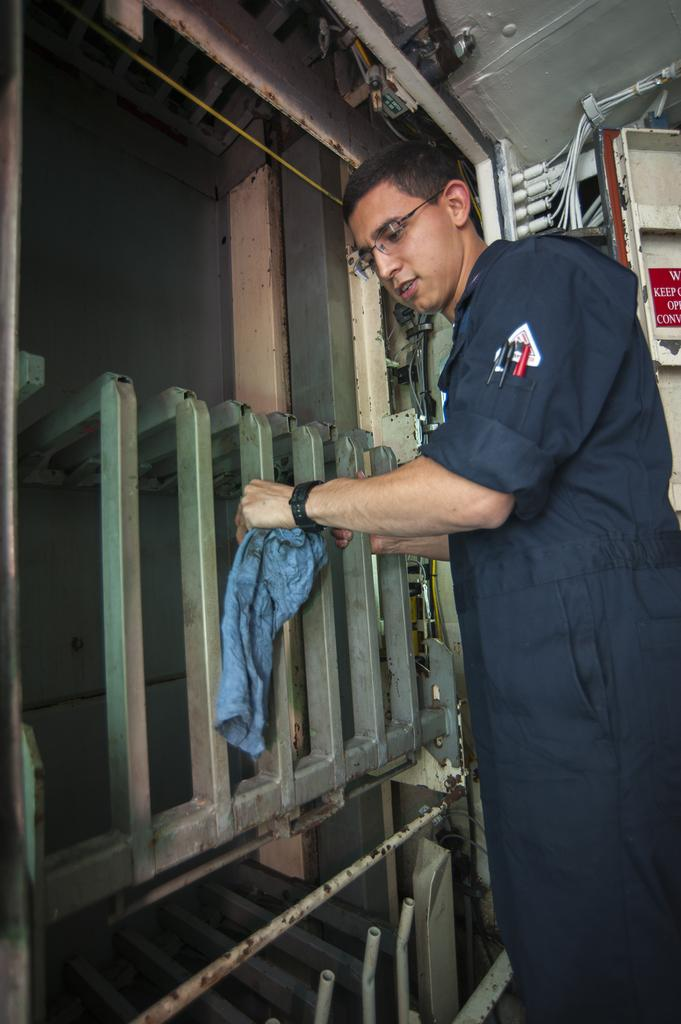What is the person in the image doing? The person is standing in the image. What is the person wearing? The person is wearing a navy blue color dress. What objects is the person holding? The person is holding a metal rod and a blue color cloth. What can be seen in the background of the image? There are wires and metal objects visible in the background of the image. What word is the person saying in the image? There is no indication in the image that the person is saying any word, as the image does not include any audio or text. 